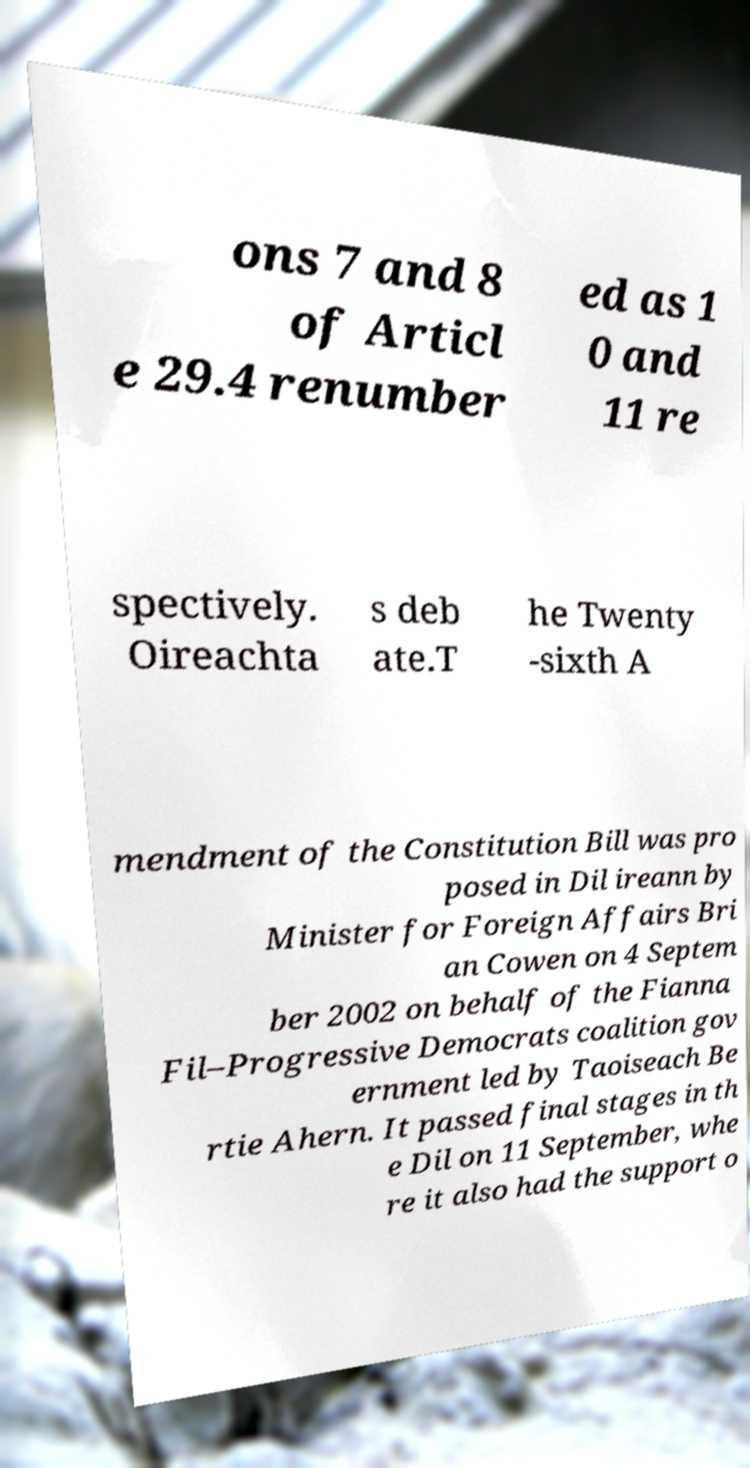Please read and relay the text visible in this image. What does it say? ons 7 and 8 of Articl e 29.4 renumber ed as 1 0 and 11 re spectively. Oireachta s deb ate.T he Twenty -sixth A mendment of the Constitution Bill was pro posed in Dil ireann by Minister for Foreign Affairs Bri an Cowen on 4 Septem ber 2002 on behalf of the Fianna Fil–Progressive Democrats coalition gov ernment led by Taoiseach Be rtie Ahern. It passed final stages in th e Dil on 11 September, whe re it also had the support o 